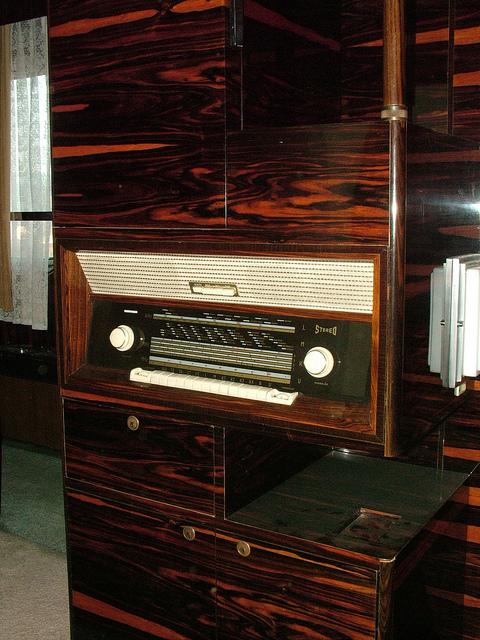Does this radio have stereo sound?
Answer briefly. No. Could this be an old receiver?
Answer briefly. Yes. What is the cabinet made of?
Quick response, please. Wood. 